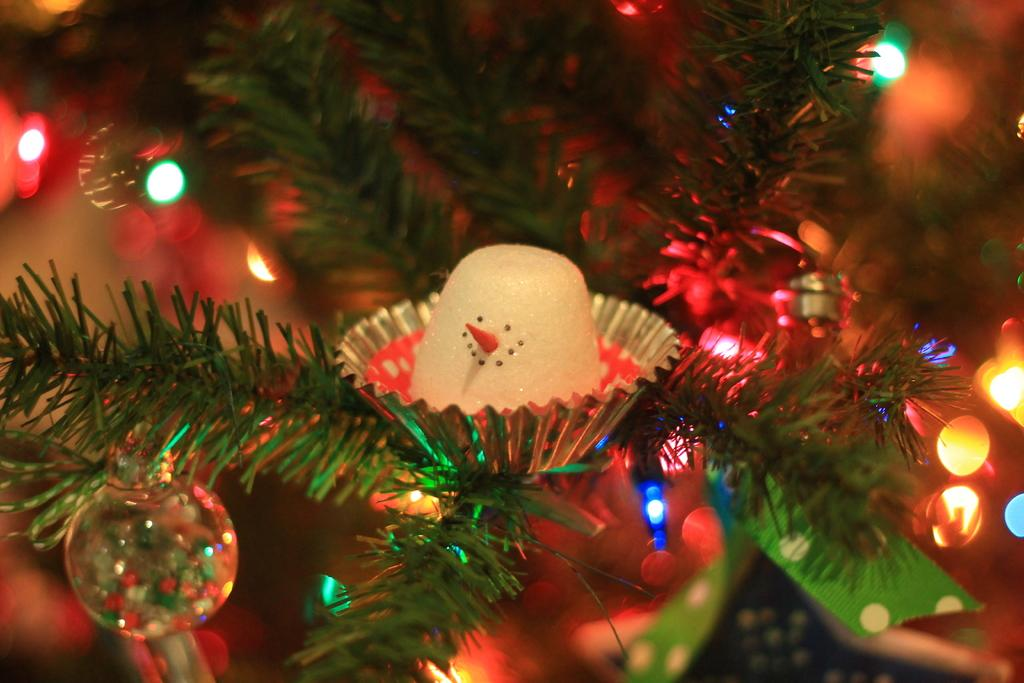What is the main object in the image? There is a tree in the image. How is the tree in the image decorated? The tree is decorated with objects. What can be seen in the background of the image? There are lights in the background of the image. What type of quill is being used by the minister in the image? There is no minister or quill present in the image; it features a decorated tree and lights in the background. 